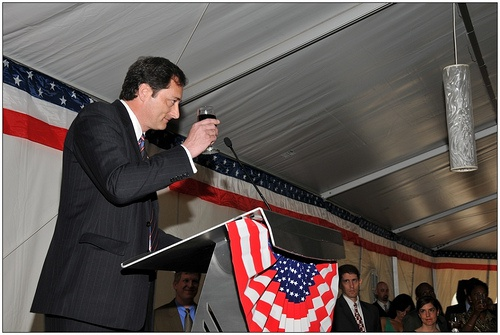Describe the objects in this image and their specific colors. I can see people in white, black, lightpink, gray, and brown tones, people in white, black, maroon, darkgray, and gray tones, people in white, black, blue, and navy tones, people in white, black, and gray tones, and people in white, black, maroon, and brown tones in this image. 